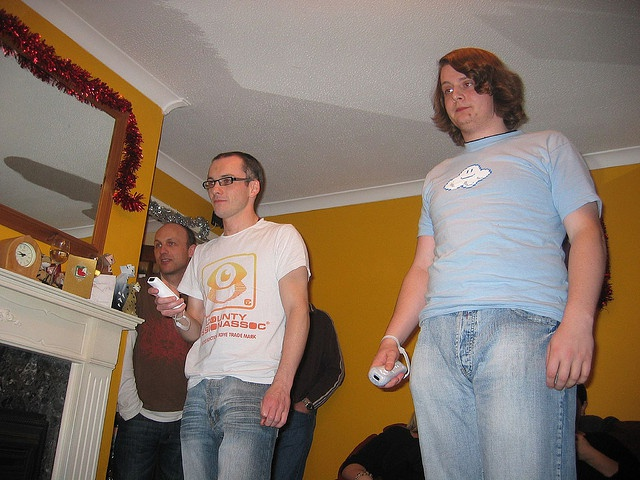Describe the objects in this image and their specific colors. I can see people in maroon, darkgray, salmon, and lightblue tones, people in maroon, lightgray, gray, salmon, and darkgray tones, people in maroon, black, darkgray, and brown tones, people in maroon, black, and gray tones, and people in black and maroon tones in this image. 